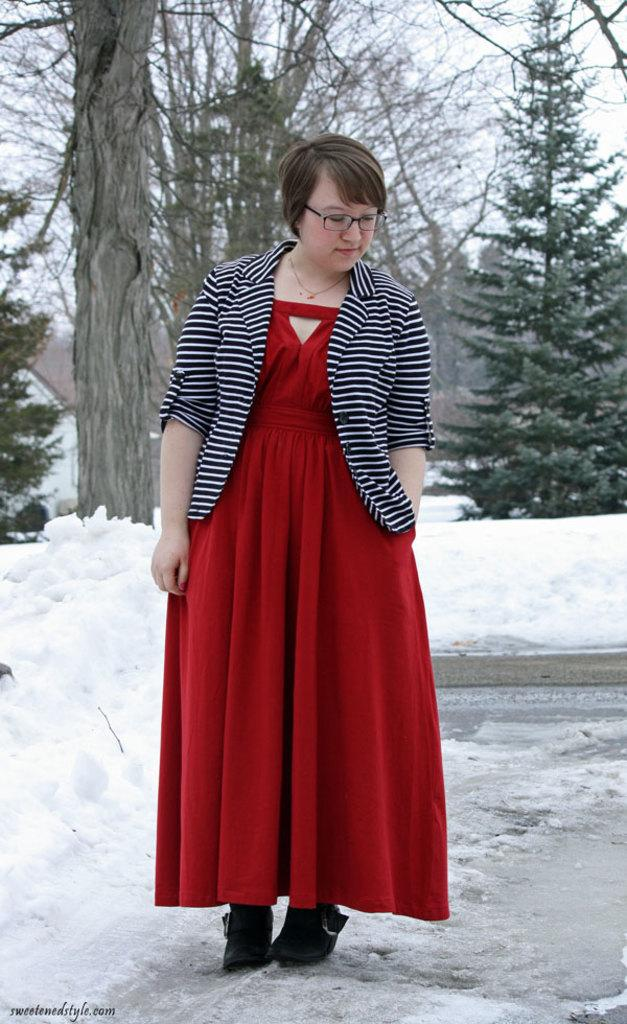Who is in the image? There is a woman in the image. What is the woman wearing? The woman is wearing a red dress and a jacket. Where is the woman standing? The woman is standing in the snow. What can be seen in the background of the image? There are trees in the background of the image. What type of bread is the woman holding in the image? There is no bread present in the image; the woman is not holding anything. 